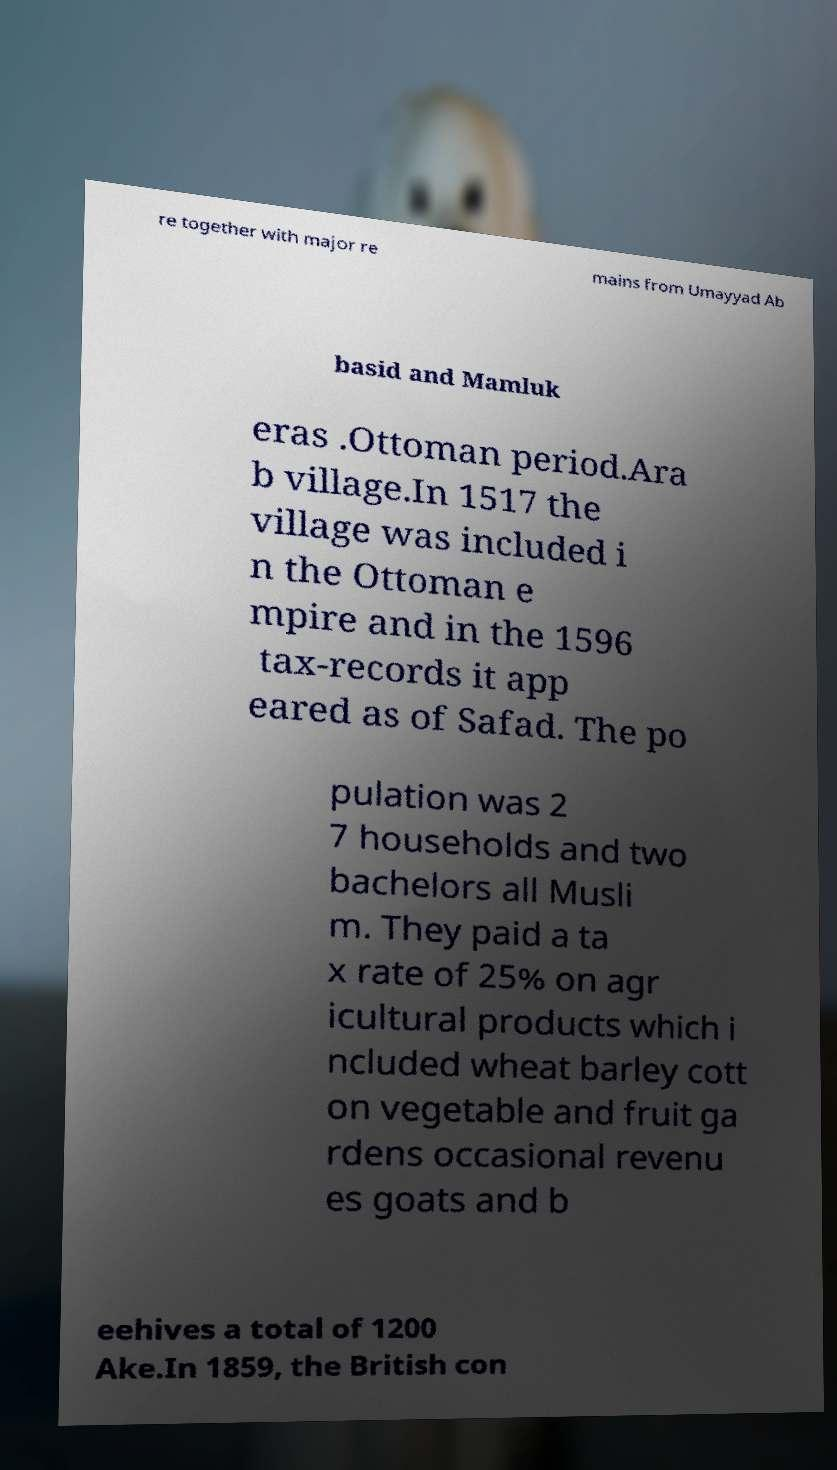There's text embedded in this image that I need extracted. Can you transcribe it verbatim? re together with major re mains from Umayyad Ab basid and Mamluk eras .Ottoman period.Ara b village.In 1517 the village was included i n the Ottoman e mpire and in the 1596 tax-records it app eared as of Safad. The po pulation was 2 7 households and two bachelors all Musli m. They paid a ta x rate of 25% on agr icultural products which i ncluded wheat barley cott on vegetable and fruit ga rdens occasional revenu es goats and b eehives a total of 1200 Ake.In 1859, the British con 